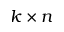Convert formula to latex. <formula><loc_0><loc_0><loc_500><loc_500>k \times n</formula> 